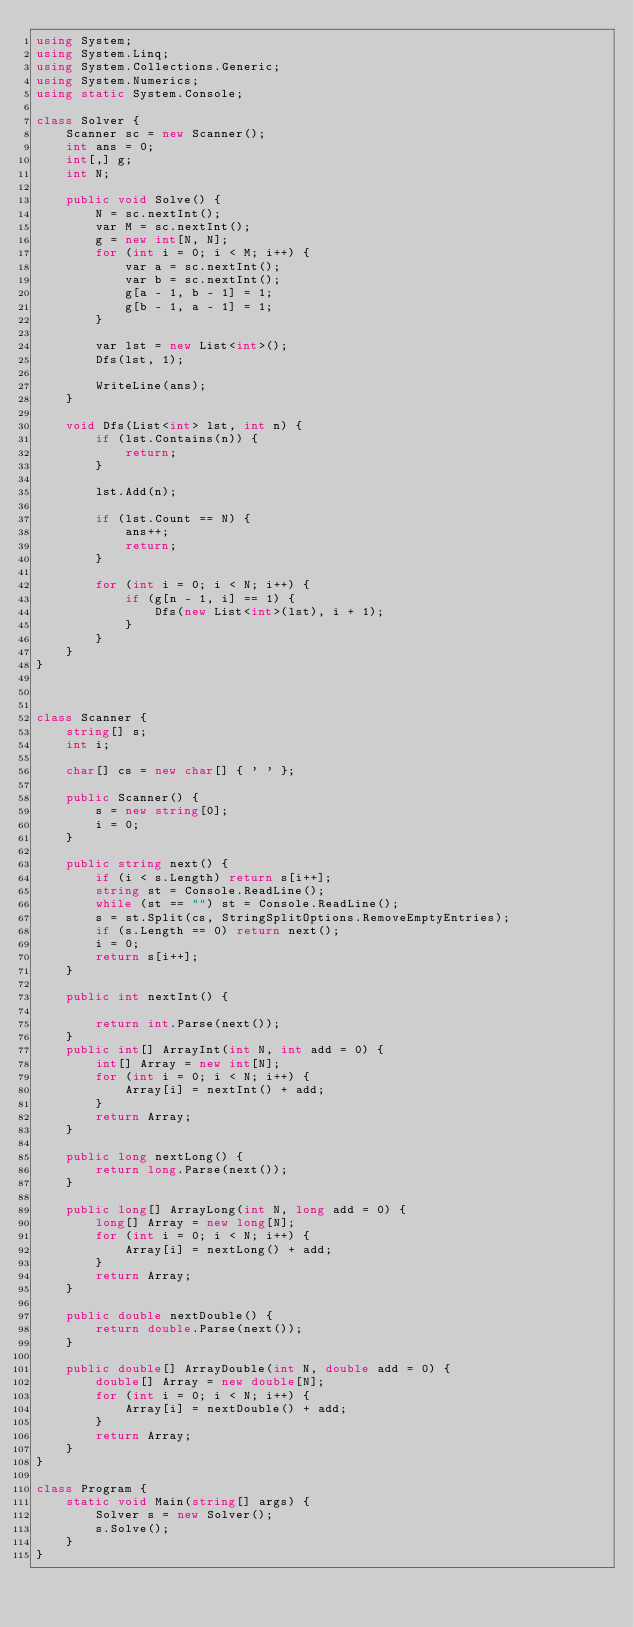Convert code to text. <code><loc_0><loc_0><loc_500><loc_500><_C#_>using System;
using System.Linq;
using System.Collections.Generic;
using System.Numerics;
using static System.Console;

class Solver {
    Scanner sc = new Scanner();
    int ans = 0;
    int[,] g;
    int N;

    public void Solve() {
        N = sc.nextInt();
        var M = sc.nextInt();
        g = new int[N, N];
        for (int i = 0; i < M; i++) {
            var a = sc.nextInt();
            var b = sc.nextInt();
            g[a - 1, b - 1] = 1;
            g[b - 1, a - 1] = 1;
        }

        var lst = new List<int>();
        Dfs(lst, 1);

        WriteLine(ans);
    }

    void Dfs(List<int> lst, int n) {
        if (lst.Contains(n)) {
            return;
        }

        lst.Add(n);

        if (lst.Count == N) {
            ans++;
            return;
        }

        for (int i = 0; i < N; i++) {
            if (g[n - 1, i] == 1) {
                Dfs(new List<int>(lst), i + 1);
            }
        }
    }
}



class Scanner {
    string[] s;
    int i;

    char[] cs = new char[] { ' ' };

    public Scanner() {
        s = new string[0];
        i = 0;
    }

    public string next() {
        if (i < s.Length) return s[i++];
        string st = Console.ReadLine();
        while (st == "") st = Console.ReadLine();
        s = st.Split(cs, StringSplitOptions.RemoveEmptyEntries);
        if (s.Length == 0) return next();
        i = 0;
        return s[i++];
    }

    public int nextInt() {

        return int.Parse(next());
    }
    public int[] ArrayInt(int N, int add = 0) {
        int[] Array = new int[N];
        for (int i = 0; i < N; i++) {
            Array[i] = nextInt() + add;
        }
        return Array;
    }

    public long nextLong() {
        return long.Parse(next());
    }

    public long[] ArrayLong(int N, long add = 0) {
        long[] Array = new long[N];
        for (int i = 0; i < N; i++) {
            Array[i] = nextLong() + add;
        }
        return Array;
    }

    public double nextDouble() {
        return double.Parse(next());
    }

    public double[] ArrayDouble(int N, double add = 0) {
        double[] Array = new double[N];
        for (int i = 0; i < N; i++) {
            Array[i] = nextDouble() + add;
        }
        return Array;
    }
}

class Program {
    static void Main(string[] args) {
        Solver s = new Solver();
        s.Solve();
    }
}</code> 